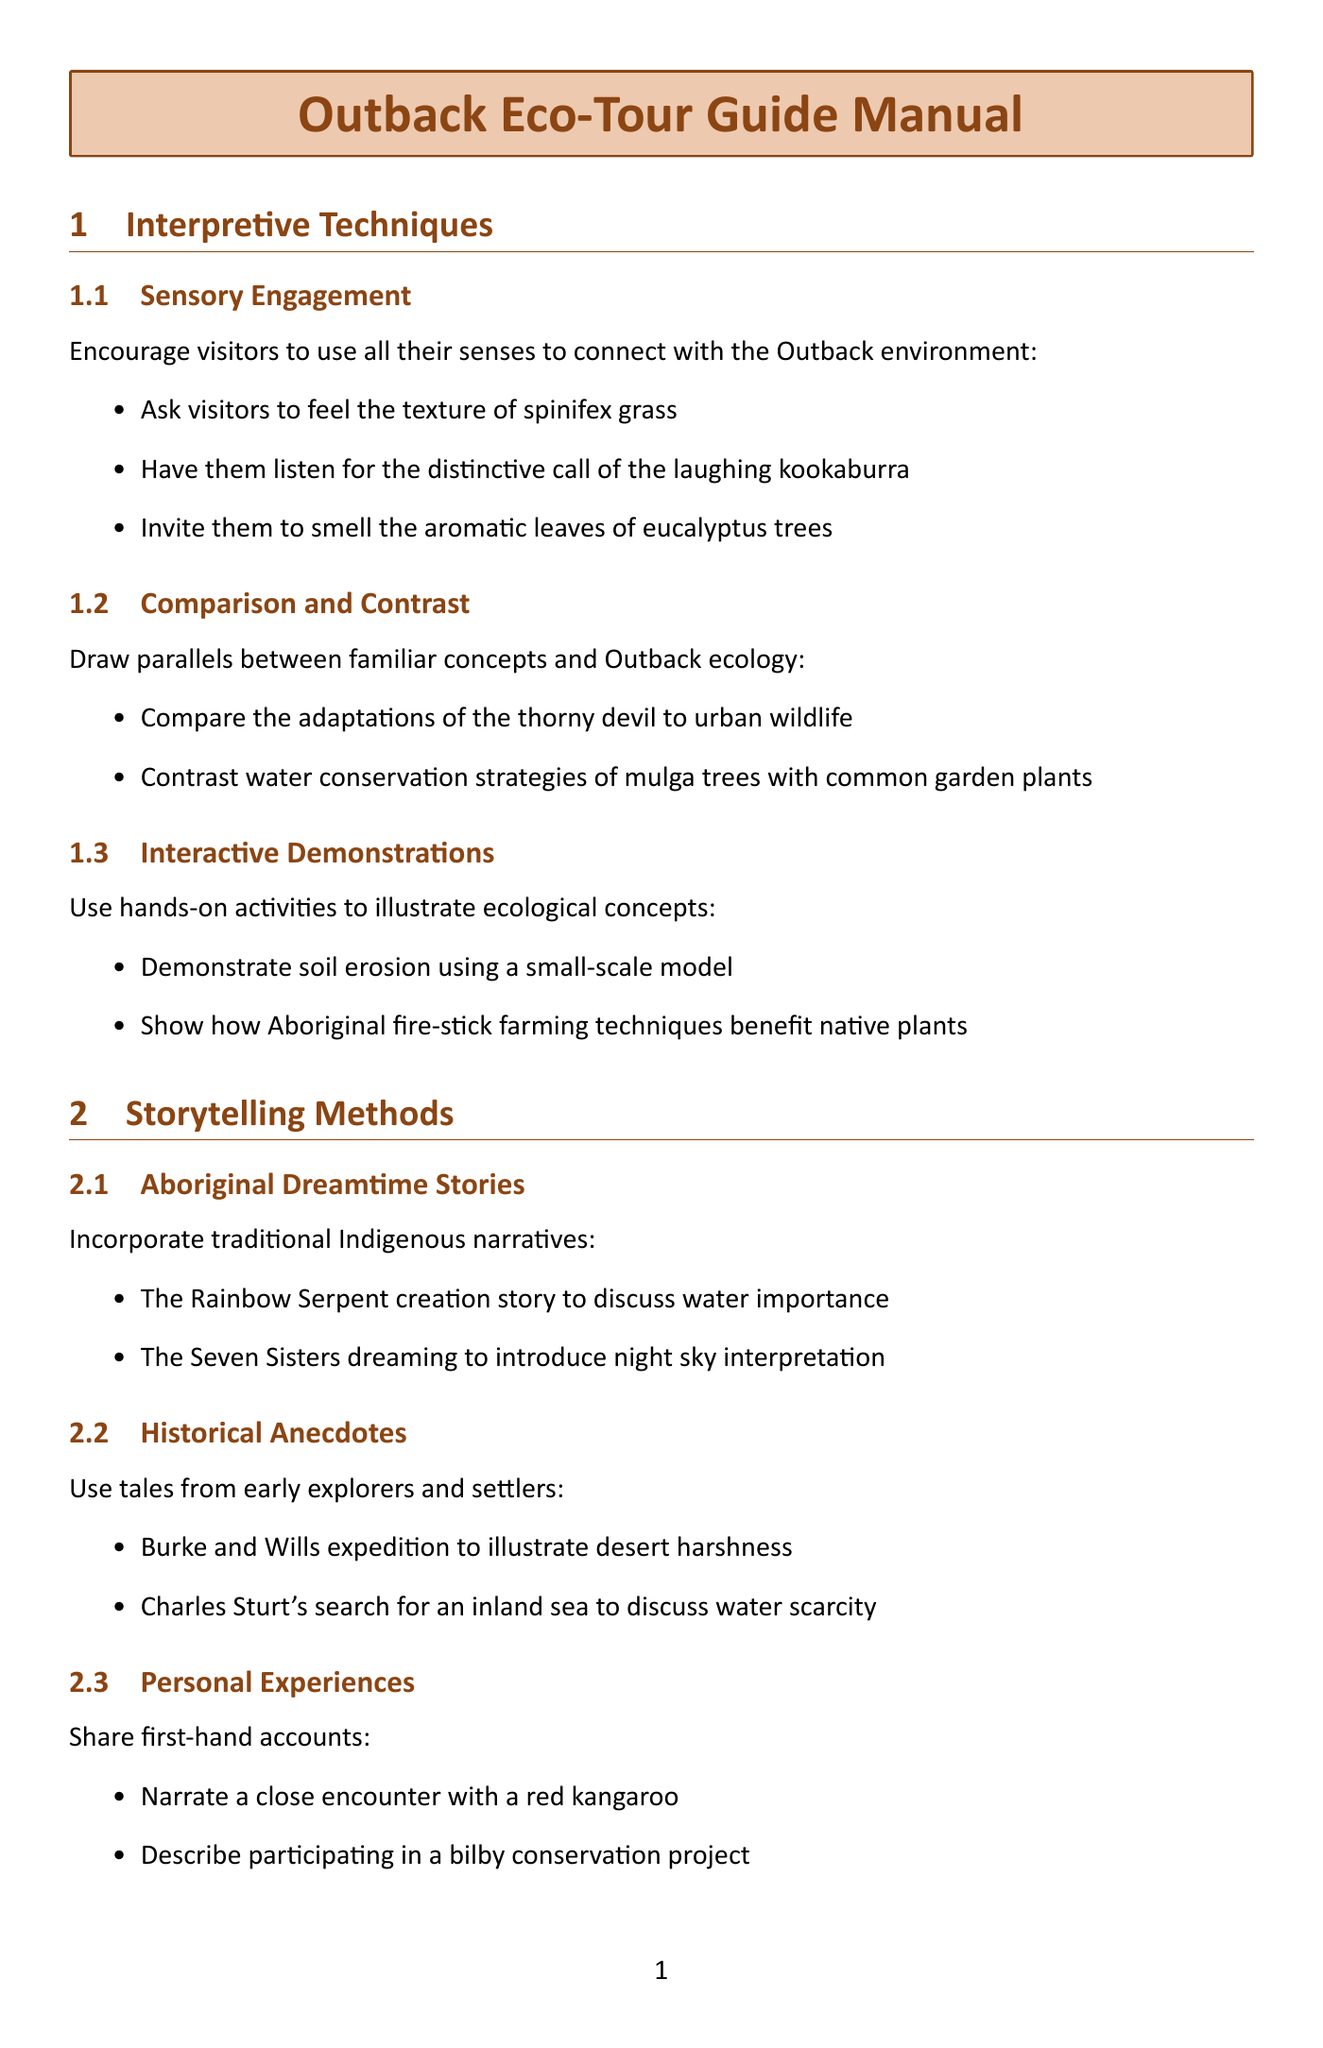What is the first interpretive technique mentioned? The document lists "Sensory Engagement" as the first interpretive technique under the section Interpretive Techniques.
Answer: Sensory Engagement How many storytelling methods are listed? The document includes three storytelling methods under the section Storytelling Methods.
Answer: 3 What ecological concept explains how flora and fauna adapt to limited water resources? "Water Scarcity" is the key ecological concept that explains these adaptations under the section Key Ecological Concepts.
Answer: Water Scarcity Which feral animal is mentioned as causing ecological damage? The document explicitly mentions "feral camels" in reference to ecological damage under the section Conservation Topics.
Answer: feral camels What is one of the citizen science projects visitors can participate in? The document states that visitors can participate in the "Australian Bird Count" as a citizen science project under the section Visitor Engagement Activities.
Answer: Australian Bird Count How does the document suggest demonstrating fire's role in ecosystems? The document suggests describing how certain plants require fire for seed germination under the section Fire Ecology in Key Ecological Concepts.
Answer: describing how certain plants require fire for seed germination What is the focus of cultural workshops mentioned? The cultural workshops are centered around hands-on experiences related to Aboriginal culture and Outback survival, as outlined in the Visitor Engagement Activities section.
Answer: Aboriginal culture and Outback survival Which adaptation method is discussed in relation to the thorny devil? The document explains how the thorny devil collects dew on its skin for hydration under the section Water Scarcity.
Answer: collects dew on its skin What type of tourism is emphasized for responsible practices? The document emphasizes "Sustainable Tourism" as a focus for educating visitors on responsible practices under the section Conservation Topics.
Answer: Sustainable Tourism 